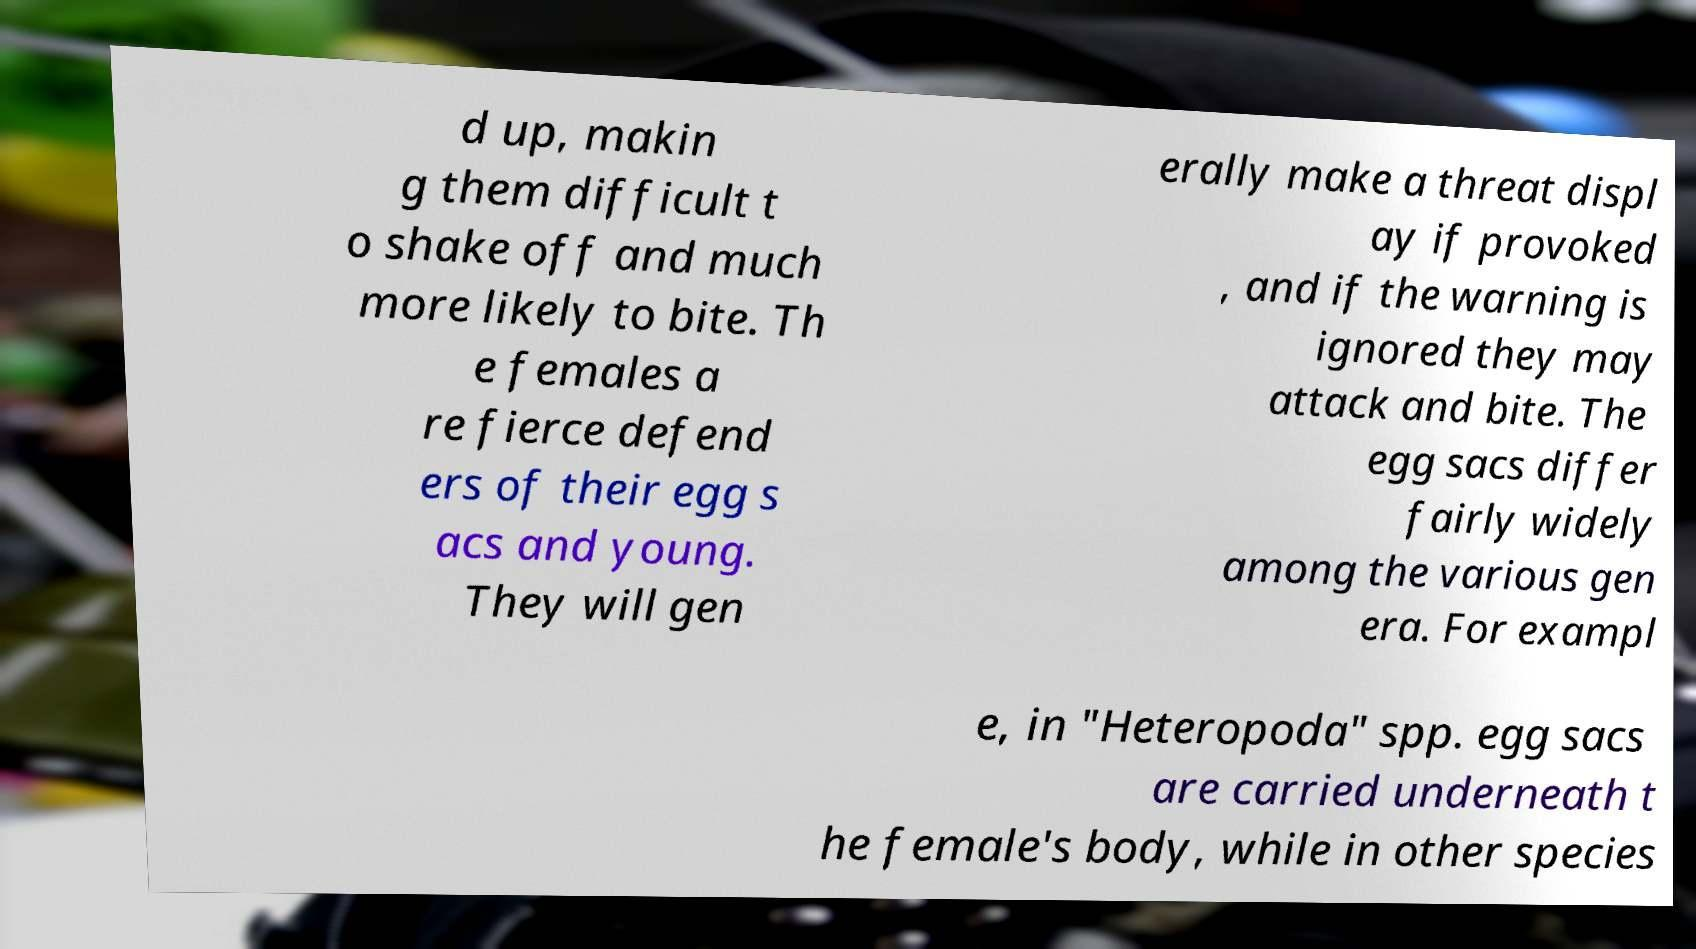Could you extract and type out the text from this image? d up, makin g them difficult t o shake off and much more likely to bite. Th e females a re fierce defend ers of their egg s acs and young. They will gen erally make a threat displ ay if provoked , and if the warning is ignored they may attack and bite. The egg sacs differ fairly widely among the various gen era. For exampl e, in "Heteropoda" spp. egg sacs are carried underneath t he female's body, while in other species 